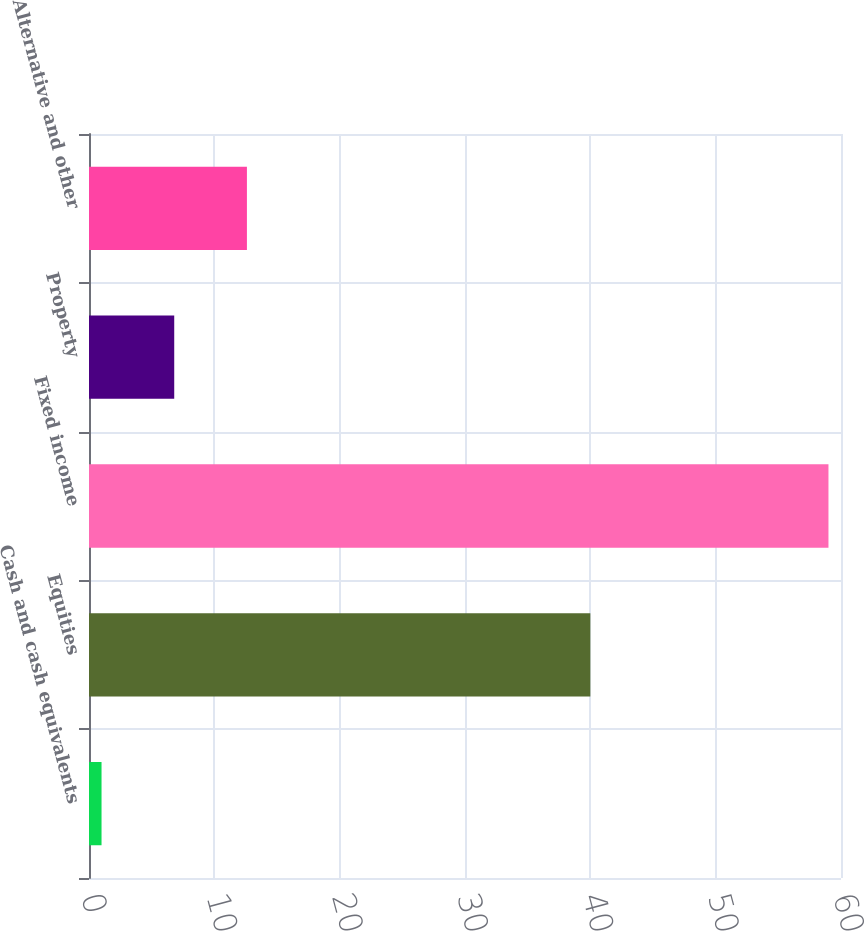<chart> <loc_0><loc_0><loc_500><loc_500><bar_chart><fcel>Cash and cash equivalents<fcel>Equities<fcel>Fixed income<fcel>Property<fcel>Alternative and other<nl><fcel>1<fcel>40<fcel>59<fcel>6.8<fcel>12.6<nl></chart> 